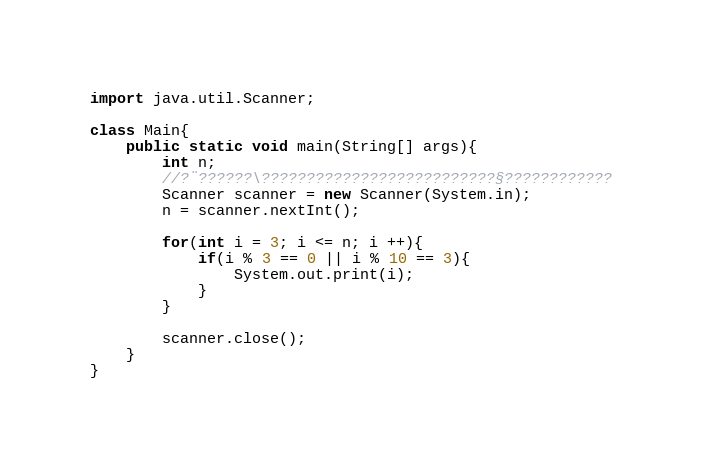<code> <loc_0><loc_0><loc_500><loc_500><_Java_>import java.util.Scanner;

class Main{
    public static void main(String[] args){
        int n;
    	//?¨??????\??????????????????????????§????????????
		Scanner scanner = new Scanner(System.in);
		n = scanner.nextInt();
		
		for(int i = 3; i <= n; i ++){
			if(i % 3 == 0 || i % 10 == 3){
				System.out.print(i);	
			}
		}
		
    	scanner.close();
    }
}</code> 